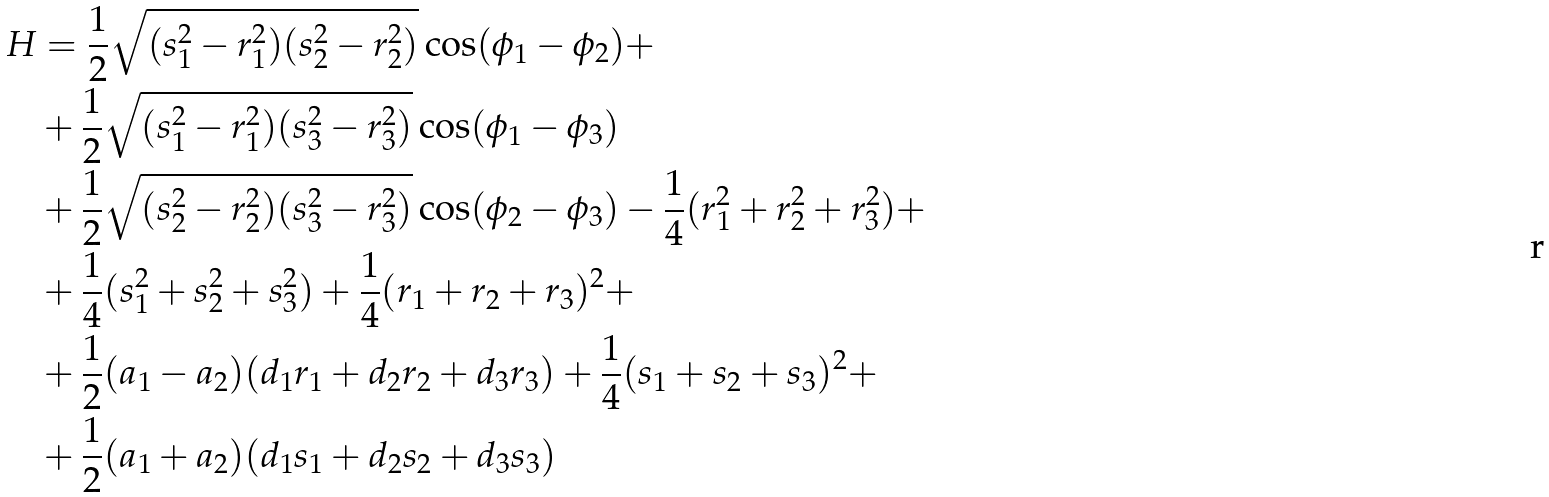<formula> <loc_0><loc_0><loc_500><loc_500>H & = \frac { 1 } { 2 } \sqrt { ( s _ { 1 } ^ { 2 } - r _ { 1 } ^ { 2 } ) ( s _ { 2 } ^ { 2 } - r _ { 2 } ^ { 2 } ) } \cos ( \phi _ { 1 } - \phi _ { 2 } ) + \\ & + \frac { 1 } { 2 } \sqrt { ( s _ { 1 } ^ { 2 } - r _ { 1 } ^ { 2 } ) ( s _ { 3 } ^ { 2 } - r _ { 3 } ^ { 2 } ) } \cos ( \phi _ { 1 } - \phi _ { 3 } ) \\ & + \frac { 1 } { 2 } \sqrt { ( s _ { 2 } ^ { 2 } - r _ { 2 } ^ { 2 } ) ( s _ { 3 } ^ { 2 } - r _ { 3 } ^ { 2 } ) } \cos ( \phi _ { 2 } - \phi _ { 3 } ) - \frac { 1 } { 4 } ( r _ { 1 } ^ { 2 } + r _ { 2 } ^ { 2 } + r _ { 3 } ^ { 2 } ) + \\ & + \frac { 1 } { 4 } ( s _ { 1 } ^ { 2 } + s _ { 2 } ^ { 2 } + s _ { 3 } ^ { 2 } ) + \frac { 1 } { 4 } ( r _ { 1 } + r _ { 2 } + r _ { 3 } ) ^ { 2 } + \\ & + \frac { 1 } { 2 } ( a _ { 1 } - a _ { 2 } ) ( d _ { 1 } r _ { 1 } + d _ { 2 } r _ { 2 } + d _ { 3 } r _ { 3 } ) + \frac { 1 } { 4 } ( s _ { 1 } + s _ { 2 } + s _ { 3 } ) ^ { 2 } + \\ & + \frac { 1 } { 2 } ( a _ { 1 } + a _ { 2 } ) ( d _ { 1 } s _ { 1 } + d _ { 2 } s _ { 2 } + d _ { 3 } s _ { 3 } )</formula> 